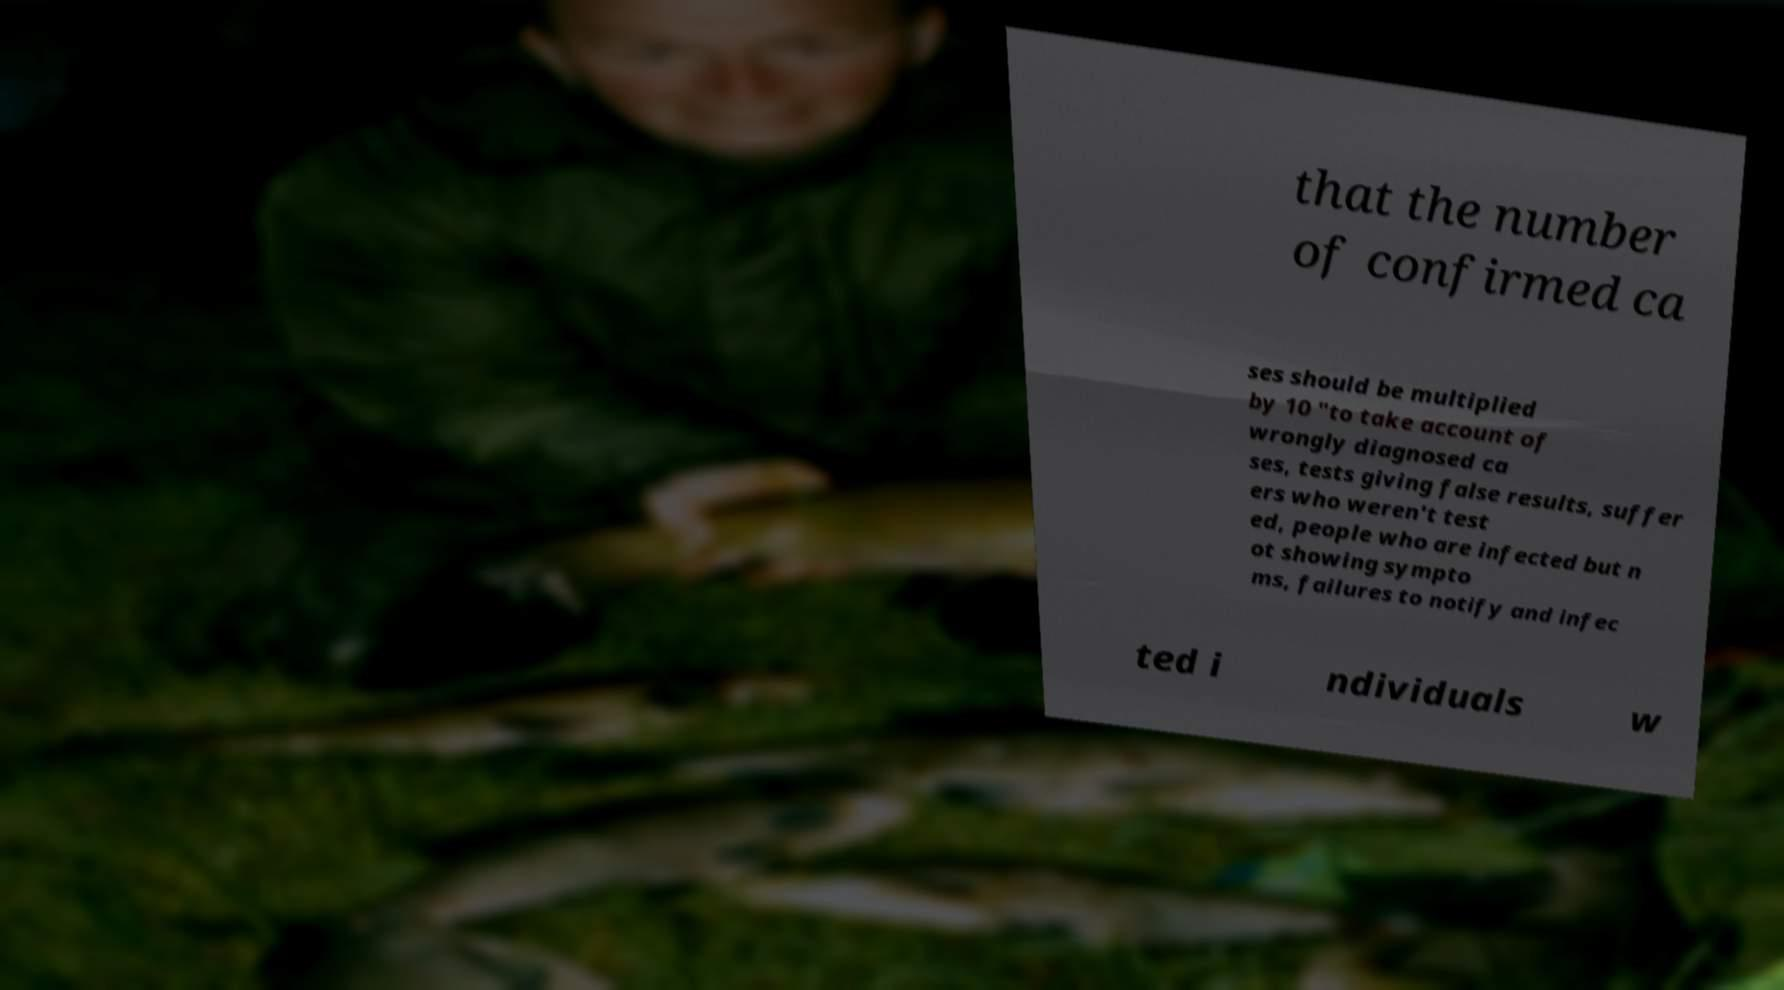For documentation purposes, I need the text within this image transcribed. Could you provide that? that the number of confirmed ca ses should be multiplied by 10 "to take account of wrongly diagnosed ca ses, tests giving false results, suffer ers who weren't test ed, people who are infected but n ot showing sympto ms, failures to notify and infec ted i ndividuals w 